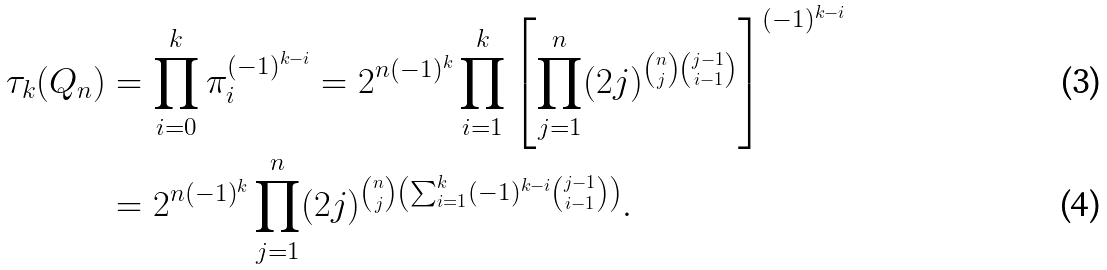Convert formula to latex. <formula><loc_0><loc_0><loc_500><loc_500>\tau _ { k } ( Q _ { n } ) & = \prod _ { i = 0 } ^ { k } \pi _ { i } ^ { ( - 1 ) ^ { k - i } } = 2 ^ { n ( - 1 ) ^ { k } } \prod _ { i = 1 } ^ { k } \left [ \prod _ { j = 1 } ^ { n } ( 2 j ) ^ { \binom { n } { j } \binom { j - 1 } { i - 1 } } \right ] ^ { ( - 1 ) ^ { k - i } } \\ & = 2 ^ { n ( - 1 ) ^ { k } } \prod _ { j = 1 } ^ { n } ( 2 j ) ^ { \binom { n } { j } \left ( \sum _ { i = 1 } ^ { k } ( - 1 ) ^ { k - i } \binom { j - 1 } { i - 1 } \right ) } .</formula> 